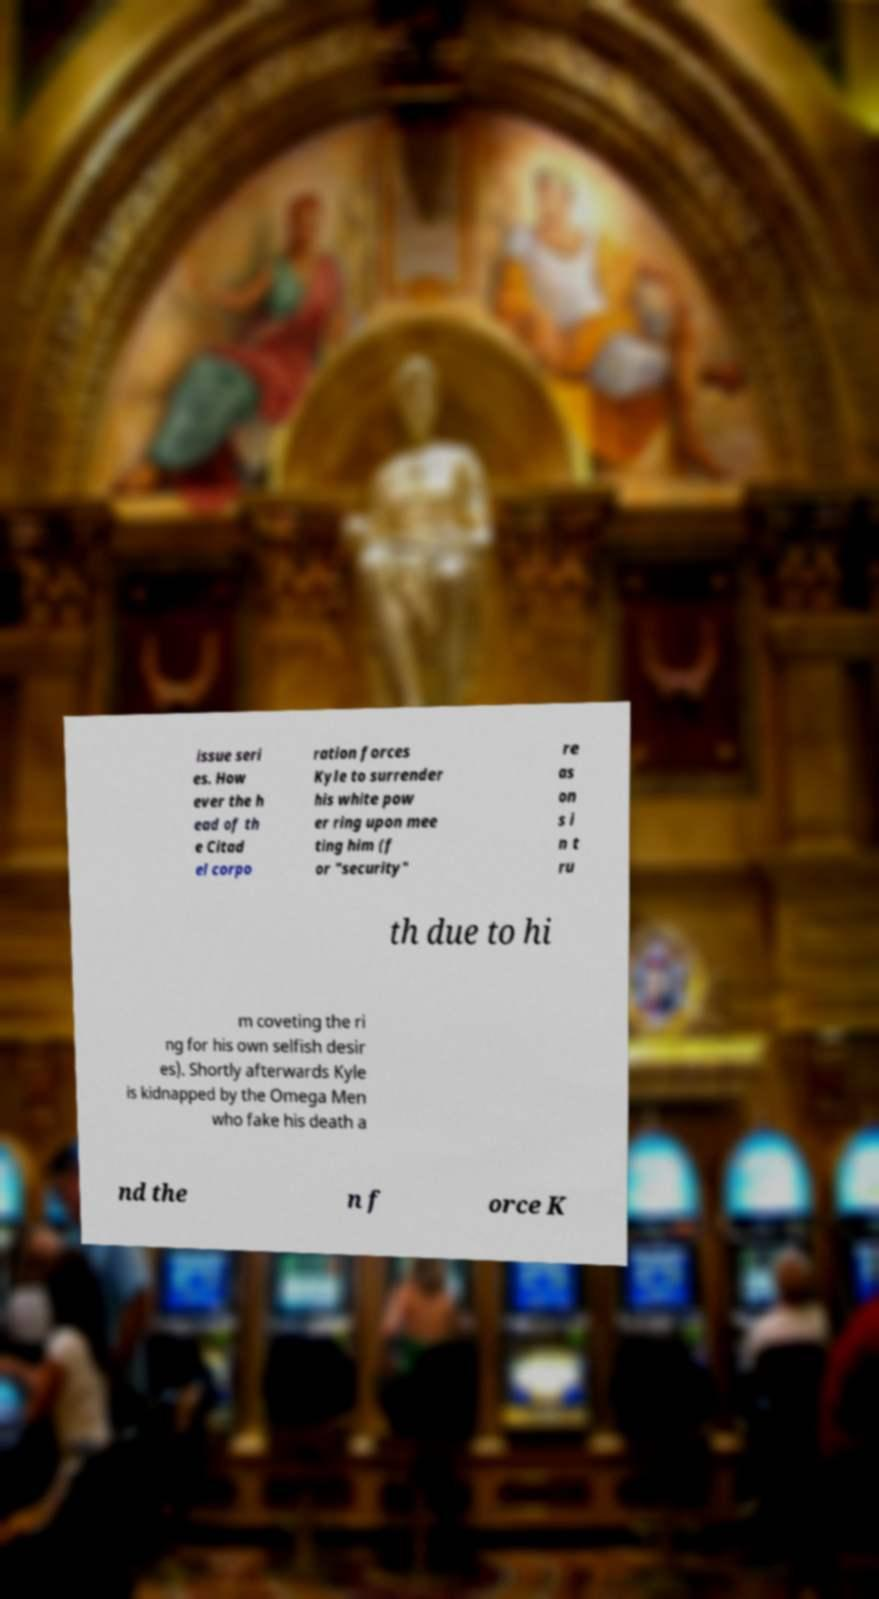Can you read and provide the text displayed in the image?This photo seems to have some interesting text. Can you extract and type it out for me? issue seri es. How ever the h ead of th e Citad el corpo ration forces Kyle to surrender his white pow er ring upon mee ting him (f or "security" re as on s i n t ru th due to hi m coveting the ri ng for his own selfish desir es). Shortly afterwards Kyle is kidnapped by the Omega Men who fake his death a nd the n f orce K 